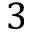<formula> <loc_0><loc_0><loc_500><loc_500>3</formula> 